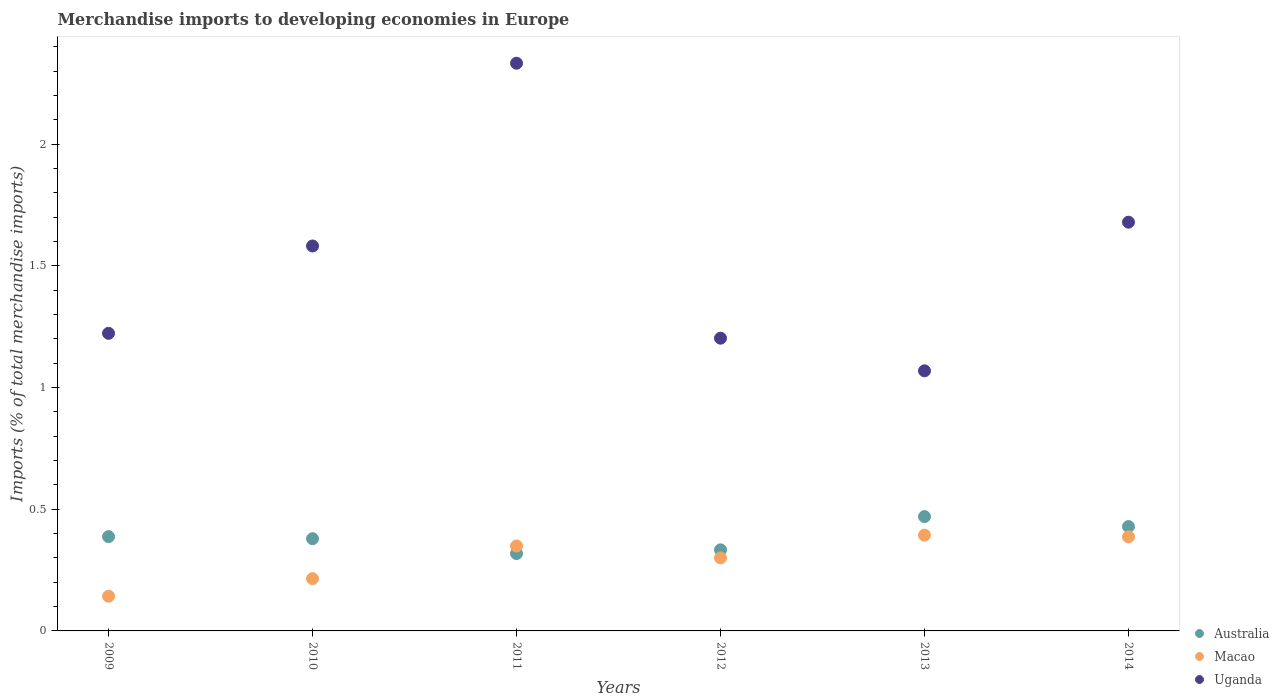How many different coloured dotlines are there?
Ensure brevity in your answer.  3. What is the percentage total merchandise imports in Australia in 2011?
Provide a short and direct response. 0.32. Across all years, what is the maximum percentage total merchandise imports in Uganda?
Your response must be concise. 2.33. Across all years, what is the minimum percentage total merchandise imports in Macao?
Provide a short and direct response. 0.14. What is the total percentage total merchandise imports in Macao in the graph?
Give a very brief answer. 1.79. What is the difference between the percentage total merchandise imports in Australia in 2009 and that in 2013?
Offer a terse response. -0.08. What is the difference between the percentage total merchandise imports in Macao in 2010 and the percentage total merchandise imports in Australia in 2009?
Provide a succinct answer. -0.17. What is the average percentage total merchandise imports in Uganda per year?
Your response must be concise. 1.52. In the year 2011, what is the difference between the percentage total merchandise imports in Uganda and percentage total merchandise imports in Macao?
Your answer should be very brief. 1.98. In how many years, is the percentage total merchandise imports in Macao greater than 1 %?
Ensure brevity in your answer.  0. What is the ratio of the percentage total merchandise imports in Uganda in 2011 to that in 2014?
Offer a terse response. 1.39. Is the difference between the percentage total merchandise imports in Uganda in 2011 and 2012 greater than the difference between the percentage total merchandise imports in Macao in 2011 and 2012?
Offer a terse response. Yes. What is the difference between the highest and the second highest percentage total merchandise imports in Australia?
Offer a very short reply. 0.04. What is the difference between the highest and the lowest percentage total merchandise imports in Australia?
Give a very brief answer. 0.15. In how many years, is the percentage total merchandise imports in Macao greater than the average percentage total merchandise imports in Macao taken over all years?
Provide a succinct answer. 4. Is the percentage total merchandise imports in Macao strictly greater than the percentage total merchandise imports in Australia over the years?
Provide a succinct answer. No. How many dotlines are there?
Your response must be concise. 3. How many years are there in the graph?
Keep it short and to the point. 6. Does the graph contain grids?
Keep it short and to the point. No. How many legend labels are there?
Ensure brevity in your answer.  3. How are the legend labels stacked?
Offer a very short reply. Vertical. What is the title of the graph?
Offer a terse response. Merchandise imports to developing economies in Europe. What is the label or title of the Y-axis?
Offer a very short reply. Imports (% of total merchandise imports). What is the Imports (% of total merchandise imports) in Australia in 2009?
Your response must be concise. 0.39. What is the Imports (% of total merchandise imports) in Macao in 2009?
Give a very brief answer. 0.14. What is the Imports (% of total merchandise imports) in Uganda in 2009?
Your answer should be compact. 1.22. What is the Imports (% of total merchandise imports) of Australia in 2010?
Your response must be concise. 0.38. What is the Imports (% of total merchandise imports) in Macao in 2010?
Offer a terse response. 0.21. What is the Imports (% of total merchandise imports) in Uganda in 2010?
Provide a short and direct response. 1.58. What is the Imports (% of total merchandise imports) in Australia in 2011?
Keep it short and to the point. 0.32. What is the Imports (% of total merchandise imports) of Macao in 2011?
Offer a very short reply. 0.35. What is the Imports (% of total merchandise imports) of Uganda in 2011?
Your answer should be very brief. 2.33. What is the Imports (% of total merchandise imports) in Australia in 2012?
Offer a very short reply. 0.33. What is the Imports (% of total merchandise imports) in Macao in 2012?
Your answer should be very brief. 0.3. What is the Imports (% of total merchandise imports) of Uganda in 2012?
Your answer should be compact. 1.2. What is the Imports (% of total merchandise imports) of Australia in 2013?
Your answer should be very brief. 0.47. What is the Imports (% of total merchandise imports) in Macao in 2013?
Offer a terse response. 0.39. What is the Imports (% of total merchandise imports) in Uganda in 2013?
Keep it short and to the point. 1.07. What is the Imports (% of total merchandise imports) of Australia in 2014?
Provide a succinct answer. 0.43. What is the Imports (% of total merchandise imports) of Macao in 2014?
Your answer should be very brief. 0.39. What is the Imports (% of total merchandise imports) of Uganda in 2014?
Ensure brevity in your answer.  1.68. Across all years, what is the maximum Imports (% of total merchandise imports) of Australia?
Provide a succinct answer. 0.47. Across all years, what is the maximum Imports (% of total merchandise imports) in Macao?
Offer a very short reply. 0.39. Across all years, what is the maximum Imports (% of total merchandise imports) of Uganda?
Keep it short and to the point. 2.33. Across all years, what is the minimum Imports (% of total merchandise imports) of Australia?
Your response must be concise. 0.32. Across all years, what is the minimum Imports (% of total merchandise imports) of Macao?
Offer a terse response. 0.14. Across all years, what is the minimum Imports (% of total merchandise imports) in Uganda?
Your answer should be compact. 1.07. What is the total Imports (% of total merchandise imports) of Australia in the graph?
Ensure brevity in your answer.  2.32. What is the total Imports (% of total merchandise imports) of Macao in the graph?
Make the answer very short. 1.79. What is the total Imports (% of total merchandise imports) of Uganda in the graph?
Give a very brief answer. 9.09. What is the difference between the Imports (% of total merchandise imports) in Australia in 2009 and that in 2010?
Keep it short and to the point. 0.01. What is the difference between the Imports (% of total merchandise imports) of Macao in 2009 and that in 2010?
Make the answer very short. -0.07. What is the difference between the Imports (% of total merchandise imports) of Uganda in 2009 and that in 2010?
Make the answer very short. -0.36. What is the difference between the Imports (% of total merchandise imports) in Australia in 2009 and that in 2011?
Make the answer very short. 0.07. What is the difference between the Imports (% of total merchandise imports) in Macao in 2009 and that in 2011?
Offer a very short reply. -0.21. What is the difference between the Imports (% of total merchandise imports) in Uganda in 2009 and that in 2011?
Provide a succinct answer. -1.11. What is the difference between the Imports (% of total merchandise imports) in Australia in 2009 and that in 2012?
Offer a terse response. 0.05. What is the difference between the Imports (% of total merchandise imports) in Macao in 2009 and that in 2012?
Keep it short and to the point. -0.16. What is the difference between the Imports (% of total merchandise imports) of Australia in 2009 and that in 2013?
Provide a short and direct response. -0.08. What is the difference between the Imports (% of total merchandise imports) of Macao in 2009 and that in 2013?
Make the answer very short. -0.25. What is the difference between the Imports (% of total merchandise imports) of Uganda in 2009 and that in 2013?
Your answer should be very brief. 0.15. What is the difference between the Imports (% of total merchandise imports) of Australia in 2009 and that in 2014?
Offer a terse response. -0.04. What is the difference between the Imports (% of total merchandise imports) of Macao in 2009 and that in 2014?
Provide a succinct answer. -0.24. What is the difference between the Imports (% of total merchandise imports) of Uganda in 2009 and that in 2014?
Offer a terse response. -0.46. What is the difference between the Imports (% of total merchandise imports) of Australia in 2010 and that in 2011?
Your response must be concise. 0.06. What is the difference between the Imports (% of total merchandise imports) in Macao in 2010 and that in 2011?
Offer a terse response. -0.13. What is the difference between the Imports (% of total merchandise imports) of Uganda in 2010 and that in 2011?
Ensure brevity in your answer.  -0.75. What is the difference between the Imports (% of total merchandise imports) of Australia in 2010 and that in 2012?
Your response must be concise. 0.05. What is the difference between the Imports (% of total merchandise imports) of Macao in 2010 and that in 2012?
Provide a succinct answer. -0.09. What is the difference between the Imports (% of total merchandise imports) of Uganda in 2010 and that in 2012?
Offer a very short reply. 0.38. What is the difference between the Imports (% of total merchandise imports) in Australia in 2010 and that in 2013?
Make the answer very short. -0.09. What is the difference between the Imports (% of total merchandise imports) of Macao in 2010 and that in 2013?
Your answer should be very brief. -0.18. What is the difference between the Imports (% of total merchandise imports) of Uganda in 2010 and that in 2013?
Make the answer very short. 0.51. What is the difference between the Imports (% of total merchandise imports) of Macao in 2010 and that in 2014?
Offer a terse response. -0.17. What is the difference between the Imports (% of total merchandise imports) in Uganda in 2010 and that in 2014?
Give a very brief answer. -0.1. What is the difference between the Imports (% of total merchandise imports) of Australia in 2011 and that in 2012?
Ensure brevity in your answer.  -0.02. What is the difference between the Imports (% of total merchandise imports) in Macao in 2011 and that in 2012?
Ensure brevity in your answer.  0.05. What is the difference between the Imports (% of total merchandise imports) of Uganda in 2011 and that in 2012?
Your response must be concise. 1.13. What is the difference between the Imports (% of total merchandise imports) of Australia in 2011 and that in 2013?
Offer a very short reply. -0.15. What is the difference between the Imports (% of total merchandise imports) of Macao in 2011 and that in 2013?
Offer a very short reply. -0.04. What is the difference between the Imports (% of total merchandise imports) in Uganda in 2011 and that in 2013?
Ensure brevity in your answer.  1.26. What is the difference between the Imports (% of total merchandise imports) in Australia in 2011 and that in 2014?
Your answer should be compact. -0.11. What is the difference between the Imports (% of total merchandise imports) of Macao in 2011 and that in 2014?
Ensure brevity in your answer.  -0.04. What is the difference between the Imports (% of total merchandise imports) of Uganda in 2011 and that in 2014?
Keep it short and to the point. 0.65. What is the difference between the Imports (% of total merchandise imports) in Australia in 2012 and that in 2013?
Your answer should be very brief. -0.14. What is the difference between the Imports (% of total merchandise imports) in Macao in 2012 and that in 2013?
Make the answer very short. -0.09. What is the difference between the Imports (% of total merchandise imports) of Uganda in 2012 and that in 2013?
Offer a very short reply. 0.13. What is the difference between the Imports (% of total merchandise imports) of Australia in 2012 and that in 2014?
Provide a short and direct response. -0.1. What is the difference between the Imports (% of total merchandise imports) of Macao in 2012 and that in 2014?
Your answer should be very brief. -0.09. What is the difference between the Imports (% of total merchandise imports) of Uganda in 2012 and that in 2014?
Make the answer very short. -0.48. What is the difference between the Imports (% of total merchandise imports) in Australia in 2013 and that in 2014?
Offer a very short reply. 0.04. What is the difference between the Imports (% of total merchandise imports) of Macao in 2013 and that in 2014?
Your answer should be very brief. 0.01. What is the difference between the Imports (% of total merchandise imports) in Uganda in 2013 and that in 2014?
Make the answer very short. -0.61. What is the difference between the Imports (% of total merchandise imports) in Australia in 2009 and the Imports (% of total merchandise imports) in Macao in 2010?
Your answer should be compact. 0.17. What is the difference between the Imports (% of total merchandise imports) in Australia in 2009 and the Imports (% of total merchandise imports) in Uganda in 2010?
Your answer should be very brief. -1.19. What is the difference between the Imports (% of total merchandise imports) in Macao in 2009 and the Imports (% of total merchandise imports) in Uganda in 2010?
Ensure brevity in your answer.  -1.44. What is the difference between the Imports (% of total merchandise imports) of Australia in 2009 and the Imports (% of total merchandise imports) of Macao in 2011?
Your response must be concise. 0.04. What is the difference between the Imports (% of total merchandise imports) in Australia in 2009 and the Imports (% of total merchandise imports) in Uganda in 2011?
Ensure brevity in your answer.  -1.95. What is the difference between the Imports (% of total merchandise imports) of Macao in 2009 and the Imports (% of total merchandise imports) of Uganda in 2011?
Give a very brief answer. -2.19. What is the difference between the Imports (% of total merchandise imports) in Australia in 2009 and the Imports (% of total merchandise imports) in Macao in 2012?
Your response must be concise. 0.09. What is the difference between the Imports (% of total merchandise imports) of Australia in 2009 and the Imports (% of total merchandise imports) of Uganda in 2012?
Provide a succinct answer. -0.82. What is the difference between the Imports (% of total merchandise imports) of Macao in 2009 and the Imports (% of total merchandise imports) of Uganda in 2012?
Provide a short and direct response. -1.06. What is the difference between the Imports (% of total merchandise imports) of Australia in 2009 and the Imports (% of total merchandise imports) of Macao in 2013?
Provide a succinct answer. -0.01. What is the difference between the Imports (% of total merchandise imports) in Australia in 2009 and the Imports (% of total merchandise imports) in Uganda in 2013?
Ensure brevity in your answer.  -0.68. What is the difference between the Imports (% of total merchandise imports) of Macao in 2009 and the Imports (% of total merchandise imports) of Uganda in 2013?
Give a very brief answer. -0.93. What is the difference between the Imports (% of total merchandise imports) of Australia in 2009 and the Imports (% of total merchandise imports) of Macao in 2014?
Make the answer very short. 0. What is the difference between the Imports (% of total merchandise imports) of Australia in 2009 and the Imports (% of total merchandise imports) of Uganda in 2014?
Provide a succinct answer. -1.29. What is the difference between the Imports (% of total merchandise imports) of Macao in 2009 and the Imports (% of total merchandise imports) of Uganda in 2014?
Give a very brief answer. -1.54. What is the difference between the Imports (% of total merchandise imports) of Australia in 2010 and the Imports (% of total merchandise imports) of Macao in 2011?
Give a very brief answer. 0.03. What is the difference between the Imports (% of total merchandise imports) of Australia in 2010 and the Imports (% of total merchandise imports) of Uganda in 2011?
Offer a very short reply. -1.95. What is the difference between the Imports (% of total merchandise imports) of Macao in 2010 and the Imports (% of total merchandise imports) of Uganda in 2011?
Give a very brief answer. -2.12. What is the difference between the Imports (% of total merchandise imports) of Australia in 2010 and the Imports (% of total merchandise imports) of Macao in 2012?
Make the answer very short. 0.08. What is the difference between the Imports (% of total merchandise imports) in Australia in 2010 and the Imports (% of total merchandise imports) in Uganda in 2012?
Your response must be concise. -0.82. What is the difference between the Imports (% of total merchandise imports) of Macao in 2010 and the Imports (% of total merchandise imports) of Uganda in 2012?
Your response must be concise. -0.99. What is the difference between the Imports (% of total merchandise imports) of Australia in 2010 and the Imports (% of total merchandise imports) of Macao in 2013?
Provide a succinct answer. -0.01. What is the difference between the Imports (% of total merchandise imports) of Australia in 2010 and the Imports (% of total merchandise imports) of Uganda in 2013?
Your answer should be very brief. -0.69. What is the difference between the Imports (% of total merchandise imports) in Macao in 2010 and the Imports (% of total merchandise imports) in Uganda in 2013?
Offer a terse response. -0.85. What is the difference between the Imports (% of total merchandise imports) in Australia in 2010 and the Imports (% of total merchandise imports) in Macao in 2014?
Offer a terse response. -0.01. What is the difference between the Imports (% of total merchandise imports) of Australia in 2010 and the Imports (% of total merchandise imports) of Uganda in 2014?
Provide a succinct answer. -1.3. What is the difference between the Imports (% of total merchandise imports) in Macao in 2010 and the Imports (% of total merchandise imports) in Uganda in 2014?
Your response must be concise. -1.47. What is the difference between the Imports (% of total merchandise imports) in Australia in 2011 and the Imports (% of total merchandise imports) in Macao in 2012?
Make the answer very short. 0.02. What is the difference between the Imports (% of total merchandise imports) of Australia in 2011 and the Imports (% of total merchandise imports) of Uganda in 2012?
Provide a succinct answer. -0.89. What is the difference between the Imports (% of total merchandise imports) in Macao in 2011 and the Imports (% of total merchandise imports) in Uganda in 2012?
Give a very brief answer. -0.85. What is the difference between the Imports (% of total merchandise imports) in Australia in 2011 and the Imports (% of total merchandise imports) in Macao in 2013?
Provide a succinct answer. -0.08. What is the difference between the Imports (% of total merchandise imports) of Australia in 2011 and the Imports (% of total merchandise imports) of Uganda in 2013?
Your response must be concise. -0.75. What is the difference between the Imports (% of total merchandise imports) in Macao in 2011 and the Imports (% of total merchandise imports) in Uganda in 2013?
Give a very brief answer. -0.72. What is the difference between the Imports (% of total merchandise imports) in Australia in 2011 and the Imports (% of total merchandise imports) in Macao in 2014?
Make the answer very short. -0.07. What is the difference between the Imports (% of total merchandise imports) in Australia in 2011 and the Imports (% of total merchandise imports) in Uganda in 2014?
Ensure brevity in your answer.  -1.36. What is the difference between the Imports (% of total merchandise imports) in Macao in 2011 and the Imports (% of total merchandise imports) in Uganda in 2014?
Provide a short and direct response. -1.33. What is the difference between the Imports (% of total merchandise imports) of Australia in 2012 and the Imports (% of total merchandise imports) of Macao in 2013?
Ensure brevity in your answer.  -0.06. What is the difference between the Imports (% of total merchandise imports) in Australia in 2012 and the Imports (% of total merchandise imports) in Uganda in 2013?
Provide a succinct answer. -0.74. What is the difference between the Imports (% of total merchandise imports) in Macao in 2012 and the Imports (% of total merchandise imports) in Uganda in 2013?
Your answer should be compact. -0.77. What is the difference between the Imports (% of total merchandise imports) in Australia in 2012 and the Imports (% of total merchandise imports) in Macao in 2014?
Offer a very short reply. -0.05. What is the difference between the Imports (% of total merchandise imports) of Australia in 2012 and the Imports (% of total merchandise imports) of Uganda in 2014?
Make the answer very short. -1.35. What is the difference between the Imports (% of total merchandise imports) in Macao in 2012 and the Imports (% of total merchandise imports) in Uganda in 2014?
Keep it short and to the point. -1.38. What is the difference between the Imports (% of total merchandise imports) of Australia in 2013 and the Imports (% of total merchandise imports) of Macao in 2014?
Give a very brief answer. 0.08. What is the difference between the Imports (% of total merchandise imports) in Australia in 2013 and the Imports (% of total merchandise imports) in Uganda in 2014?
Your answer should be very brief. -1.21. What is the difference between the Imports (% of total merchandise imports) of Macao in 2013 and the Imports (% of total merchandise imports) of Uganda in 2014?
Your response must be concise. -1.29. What is the average Imports (% of total merchandise imports) in Australia per year?
Keep it short and to the point. 0.39. What is the average Imports (% of total merchandise imports) of Macao per year?
Give a very brief answer. 0.3. What is the average Imports (% of total merchandise imports) of Uganda per year?
Your answer should be very brief. 1.52. In the year 2009, what is the difference between the Imports (% of total merchandise imports) in Australia and Imports (% of total merchandise imports) in Macao?
Offer a very short reply. 0.24. In the year 2009, what is the difference between the Imports (% of total merchandise imports) in Australia and Imports (% of total merchandise imports) in Uganda?
Give a very brief answer. -0.84. In the year 2009, what is the difference between the Imports (% of total merchandise imports) of Macao and Imports (% of total merchandise imports) of Uganda?
Make the answer very short. -1.08. In the year 2010, what is the difference between the Imports (% of total merchandise imports) in Australia and Imports (% of total merchandise imports) in Macao?
Your answer should be very brief. 0.16. In the year 2010, what is the difference between the Imports (% of total merchandise imports) of Australia and Imports (% of total merchandise imports) of Uganda?
Your answer should be very brief. -1.2. In the year 2010, what is the difference between the Imports (% of total merchandise imports) in Macao and Imports (% of total merchandise imports) in Uganda?
Make the answer very short. -1.37. In the year 2011, what is the difference between the Imports (% of total merchandise imports) of Australia and Imports (% of total merchandise imports) of Macao?
Your answer should be very brief. -0.03. In the year 2011, what is the difference between the Imports (% of total merchandise imports) of Australia and Imports (% of total merchandise imports) of Uganda?
Ensure brevity in your answer.  -2.02. In the year 2011, what is the difference between the Imports (% of total merchandise imports) of Macao and Imports (% of total merchandise imports) of Uganda?
Your answer should be very brief. -1.98. In the year 2012, what is the difference between the Imports (% of total merchandise imports) in Australia and Imports (% of total merchandise imports) in Macao?
Offer a terse response. 0.03. In the year 2012, what is the difference between the Imports (% of total merchandise imports) in Australia and Imports (% of total merchandise imports) in Uganda?
Provide a short and direct response. -0.87. In the year 2012, what is the difference between the Imports (% of total merchandise imports) in Macao and Imports (% of total merchandise imports) in Uganda?
Offer a terse response. -0.9. In the year 2013, what is the difference between the Imports (% of total merchandise imports) in Australia and Imports (% of total merchandise imports) in Macao?
Give a very brief answer. 0.08. In the year 2013, what is the difference between the Imports (% of total merchandise imports) of Australia and Imports (% of total merchandise imports) of Uganda?
Ensure brevity in your answer.  -0.6. In the year 2013, what is the difference between the Imports (% of total merchandise imports) of Macao and Imports (% of total merchandise imports) of Uganda?
Give a very brief answer. -0.68. In the year 2014, what is the difference between the Imports (% of total merchandise imports) of Australia and Imports (% of total merchandise imports) of Macao?
Provide a succinct answer. 0.04. In the year 2014, what is the difference between the Imports (% of total merchandise imports) of Australia and Imports (% of total merchandise imports) of Uganda?
Make the answer very short. -1.25. In the year 2014, what is the difference between the Imports (% of total merchandise imports) in Macao and Imports (% of total merchandise imports) in Uganda?
Provide a short and direct response. -1.29. What is the ratio of the Imports (% of total merchandise imports) of Australia in 2009 to that in 2010?
Offer a very short reply. 1.02. What is the ratio of the Imports (% of total merchandise imports) of Macao in 2009 to that in 2010?
Your answer should be compact. 0.66. What is the ratio of the Imports (% of total merchandise imports) of Uganda in 2009 to that in 2010?
Provide a succinct answer. 0.77. What is the ratio of the Imports (% of total merchandise imports) in Australia in 2009 to that in 2011?
Your response must be concise. 1.22. What is the ratio of the Imports (% of total merchandise imports) of Macao in 2009 to that in 2011?
Give a very brief answer. 0.41. What is the ratio of the Imports (% of total merchandise imports) in Uganda in 2009 to that in 2011?
Provide a short and direct response. 0.52. What is the ratio of the Imports (% of total merchandise imports) in Australia in 2009 to that in 2012?
Keep it short and to the point. 1.16. What is the ratio of the Imports (% of total merchandise imports) of Macao in 2009 to that in 2012?
Offer a terse response. 0.47. What is the ratio of the Imports (% of total merchandise imports) in Uganda in 2009 to that in 2012?
Your response must be concise. 1.02. What is the ratio of the Imports (% of total merchandise imports) in Australia in 2009 to that in 2013?
Keep it short and to the point. 0.82. What is the ratio of the Imports (% of total merchandise imports) of Macao in 2009 to that in 2013?
Give a very brief answer. 0.36. What is the ratio of the Imports (% of total merchandise imports) in Uganda in 2009 to that in 2013?
Your answer should be very brief. 1.14. What is the ratio of the Imports (% of total merchandise imports) in Australia in 2009 to that in 2014?
Provide a short and direct response. 0.9. What is the ratio of the Imports (% of total merchandise imports) of Macao in 2009 to that in 2014?
Your answer should be compact. 0.37. What is the ratio of the Imports (% of total merchandise imports) of Uganda in 2009 to that in 2014?
Keep it short and to the point. 0.73. What is the ratio of the Imports (% of total merchandise imports) in Australia in 2010 to that in 2011?
Offer a terse response. 1.19. What is the ratio of the Imports (% of total merchandise imports) of Macao in 2010 to that in 2011?
Give a very brief answer. 0.62. What is the ratio of the Imports (% of total merchandise imports) of Uganda in 2010 to that in 2011?
Offer a very short reply. 0.68. What is the ratio of the Imports (% of total merchandise imports) in Australia in 2010 to that in 2012?
Give a very brief answer. 1.14. What is the ratio of the Imports (% of total merchandise imports) in Macao in 2010 to that in 2012?
Make the answer very short. 0.72. What is the ratio of the Imports (% of total merchandise imports) of Uganda in 2010 to that in 2012?
Offer a very short reply. 1.31. What is the ratio of the Imports (% of total merchandise imports) of Australia in 2010 to that in 2013?
Ensure brevity in your answer.  0.81. What is the ratio of the Imports (% of total merchandise imports) in Macao in 2010 to that in 2013?
Provide a succinct answer. 0.55. What is the ratio of the Imports (% of total merchandise imports) of Uganda in 2010 to that in 2013?
Ensure brevity in your answer.  1.48. What is the ratio of the Imports (% of total merchandise imports) of Australia in 2010 to that in 2014?
Ensure brevity in your answer.  0.88. What is the ratio of the Imports (% of total merchandise imports) of Macao in 2010 to that in 2014?
Offer a terse response. 0.56. What is the ratio of the Imports (% of total merchandise imports) in Uganda in 2010 to that in 2014?
Keep it short and to the point. 0.94. What is the ratio of the Imports (% of total merchandise imports) of Australia in 2011 to that in 2012?
Your answer should be very brief. 0.95. What is the ratio of the Imports (% of total merchandise imports) in Macao in 2011 to that in 2012?
Your response must be concise. 1.16. What is the ratio of the Imports (% of total merchandise imports) of Uganda in 2011 to that in 2012?
Offer a very short reply. 1.94. What is the ratio of the Imports (% of total merchandise imports) of Australia in 2011 to that in 2013?
Provide a short and direct response. 0.68. What is the ratio of the Imports (% of total merchandise imports) of Macao in 2011 to that in 2013?
Offer a very short reply. 0.89. What is the ratio of the Imports (% of total merchandise imports) of Uganda in 2011 to that in 2013?
Keep it short and to the point. 2.18. What is the ratio of the Imports (% of total merchandise imports) in Australia in 2011 to that in 2014?
Give a very brief answer. 0.74. What is the ratio of the Imports (% of total merchandise imports) of Macao in 2011 to that in 2014?
Offer a very short reply. 0.9. What is the ratio of the Imports (% of total merchandise imports) in Uganda in 2011 to that in 2014?
Provide a succinct answer. 1.39. What is the ratio of the Imports (% of total merchandise imports) of Australia in 2012 to that in 2013?
Your answer should be compact. 0.71. What is the ratio of the Imports (% of total merchandise imports) of Macao in 2012 to that in 2013?
Keep it short and to the point. 0.76. What is the ratio of the Imports (% of total merchandise imports) in Uganda in 2012 to that in 2013?
Give a very brief answer. 1.13. What is the ratio of the Imports (% of total merchandise imports) of Australia in 2012 to that in 2014?
Offer a very short reply. 0.78. What is the ratio of the Imports (% of total merchandise imports) in Macao in 2012 to that in 2014?
Your answer should be very brief. 0.78. What is the ratio of the Imports (% of total merchandise imports) of Uganda in 2012 to that in 2014?
Ensure brevity in your answer.  0.72. What is the ratio of the Imports (% of total merchandise imports) in Australia in 2013 to that in 2014?
Make the answer very short. 1.1. What is the ratio of the Imports (% of total merchandise imports) in Macao in 2013 to that in 2014?
Provide a short and direct response. 1.02. What is the ratio of the Imports (% of total merchandise imports) of Uganda in 2013 to that in 2014?
Provide a short and direct response. 0.64. What is the difference between the highest and the second highest Imports (% of total merchandise imports) of Australia?
Provide a succinct answer. 0.04. What is the difference between the highest and the second highest Imports (% of total merchandise imports) of Macao?
Offer a very short reply. 0.01. What is the difference between the highest and the second highest Imports (% of total merchandise imports) in Uganda?
Your answer should be very brief. 0.65. What is the difference between the highest and the lowest Imports (% of total merchandise imports) in Australia?
Your answer should be compact. 0.15. What is the difference between the highest and the lowest Imports (% of total merchandise imports) in Macao?
Provide a short and direct response. 0.25. What is the difference between the highest and the lowest Imports (% of total merchandise imports) of Uganda?
Offer a terse response. 1.26. 